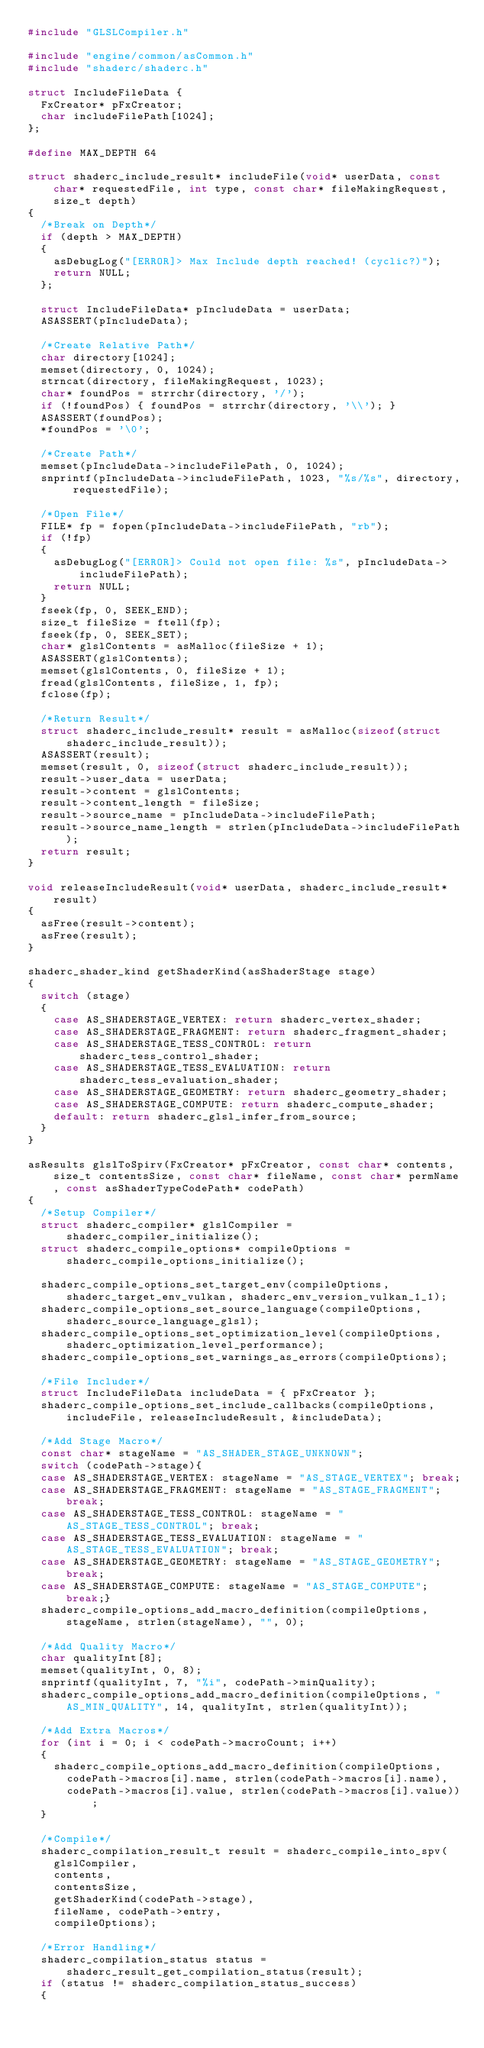<code> <loc_0><loc_0><loc_500><loc_500><_C_>#include "GLSLCompiler.h"

#include "engine/common/asCommon.h"
#include "shaderc/shaderc.h"

struct IncludeFileData {
	FxCreator* pFxCreator;
	char includeFilePath[1024];
};

#define MAX_DEPTH 64

struct shaderc_include_result* includeFile(void* userData, const char* requestedFile, int type, const char* fileMakingRequest, size_t depth)
{
	/*Break on Depth*/
	if (depth > MAX_DEPTH) 
	{
		asDebugLog("[ERROR]> Max Include depth reached! (cyclic?)");
		return NULL;
	};

	struct IncludeFileData* pIncludeData = userData;
	ASASSERT(pIncludeData);

	/*Create Relative Path*/
	char directory[1024];
	memset(directory, 0, 1024);
	strncat(directory, fileMakingRequest, 1023);
	char* foundPos = strrchr(directory, '/');
	if (!foundPos) { foundPos = strrchr(directory, '\\'); }
	ASASSERT(foundPos);
	*foundPos = '\0';

	/*Create Path*/
	memset(pIncludeData->includeFilePath, 0, 1024);
	snprintf(pIncludeData->includeFilePath, 1023, "%s/%s", directory, requestedFile);

	/*Open File*/
	FILE* fp = fopen(pIncludeData->includeFilePath, "rb");
	if (!fp)
	{
		asDebugLog("[ERROR]> Could not open file: %s", pIncludeData->includeFilePath);
		return NULL;
	}
	fseek(fp, 0, SEEK_END);
	size_t fileSize = ftell(fp);
	fseek(fp, 0, SEEK_SET);
	char* glslContents = asMalloc(fileSize + 1);
	ASASSERT(glslContents);
	memset(glslContents, 0, fileSize + 1);
	fread(glslContents, fileSize, 1, fp);
	fclose(fp);

	/*Return Result*/
	struct shaderc_include_result* result = asMalloc(sizeof(struct shaderc_include_result));
	ASASSERT(result);
	memset(result, 0, sizeof(struct shaderc_include_result));
	result->user_data = userData;
	result->content = glslContents;
	result->content_length = fileSize;
	result->source_name = pIncludeData->includeFilePath;
	result->source_name_length = strlen(pIncludeData->includeFilePath);
	return result;
}

void releaseIncludeResult(void* userData, shaderc_include_result* result)
{
	asFree(result->content);
	asFree(result);
}

shaderc_shader_kind getShaderKind(asShaderStage stage)
{
	switch (stage)
	{
		case AS_SHADERSTAGE_VERTEX: return shaderc_vertex_shader;
		case AS_SHADERSTAGE_FRAGMENT: return shaderc_fragment_shader;
		case AS_SHADERSTAGE_TESS_CONTROL: return shaderc_tess_control_shader;
		case AS_SHADERSTAGE_TESS_EVALUATION: return shaderc_tess_evaluation_shader;
		case AS_SHADERSTAGE_GEOMETRY: return shaderc_geometry_shader;
		case AS_SHADERSTAGE_COMPUTE: return shaderc_compute_shader;
		default: return shaderc_glsl_infer_from_source;
	}
}

asResults glslToSpirv(FxCreator* pFxCreator, const char* contents, size_t contentsSize, const char* fileName, const char* permName, const asShaderTypeCodePath* codePath)
{
	/*Setup Compiler*/
	struct shaderc_compiler* glslCompiler = shaderc_compiler_initialize();
	struct shaderc_compile_options* compileOptions = shaderc_compile_options_initialize();
	
	shaderc_compile_options_set_target_env(compileOptions, shaderc_target_env_vulkan, shaderc_env_version_vulkan_1_1);
	shaderc_compile_options_set_source_language(compileOptions, shaderc_source_language_glsl);
	shaderc_compile_options_set_optimization_level(compileOptions, shaderc_optimization_level_performance);
	shaderc_compile_options_set_warnings_as_errors(compileOptions);

	/*File Includer*/
	struct IncludeFileData includeData = { pFxCreator };
	shaderc_compile_options_set_include_callbacks(compileOptions, includeFile, releaseIncludeResult, &includeData);

	/*Add Stage Macro*/
	const char* stageName = "AS_SHADER_STAGE_UNKNOWN";
	switch (codePath->stage){
	case AS_SHADERSTAGE_VERTEX: stageName = "AS_STAGE_VERTEX"; break;
	case AS_SHADERSTAGE_FRAGMENT: stageName = "AS_STAGE_FRAGMENT"; break;
	case AS_SHADERSTAGE_TESS_CONTROL: stageName = "AS_STAGE_TESS_CONTROL"; break;
	case AS_SHADERSTAGE_TESS_EVALUATION: stageName = "AS_STAGE_TESS_EVALUATION"; break;
	case AS_SHADERSTAGE_GEOMETRY: stageName = "AS_STAGE_GEOMETRY"; break;
	case AS_SHADERSTAGE_COMPUTE: stageName = "AS_STAGE_COMPUTE"; break;}
	shaderc_compile_options_add_macro_definition(compileOptions, stageName, strlen(stageName), "", 0);

	/*Add Quality Macro*/
	char qualityInt[8];
	memset(qualityInt, 0, 8);
	snprintf(qualityInt, 7, "%i", codePath->minQuality);
	shaderc_compile_options_add_macro_definition(compileOptions, "AS_MIN_QUALITY", 14, qualityInt, strlen(qualityInt));

	/*Add Extra Macros*/
	for (int i = 0; i < codePath->macroCount; i++)
	{
		shaderc_compile_options_add_macro_definition(compileOptions,
			codePath->macros[i].name, strlen(codePath->macros[i].name),
			codePath->macros[i].value, strlen(codePath->macros[i].value));
	}

	/*Compile*/
	shaderc_compilation_result_t result = shaderc_compile_into_spv(
		glslCompiler,
		contents,
		contentsSize,
		getShaderKind(codePath->stage),
		fileName, codePath->entry,
		compileOptions);

	/*Error Handling*/
	shaderc_compilation_status status = shaderc_result_get_compilation_status(result);
	if (status != shaderc_compilation_status_success)
	{</code> 